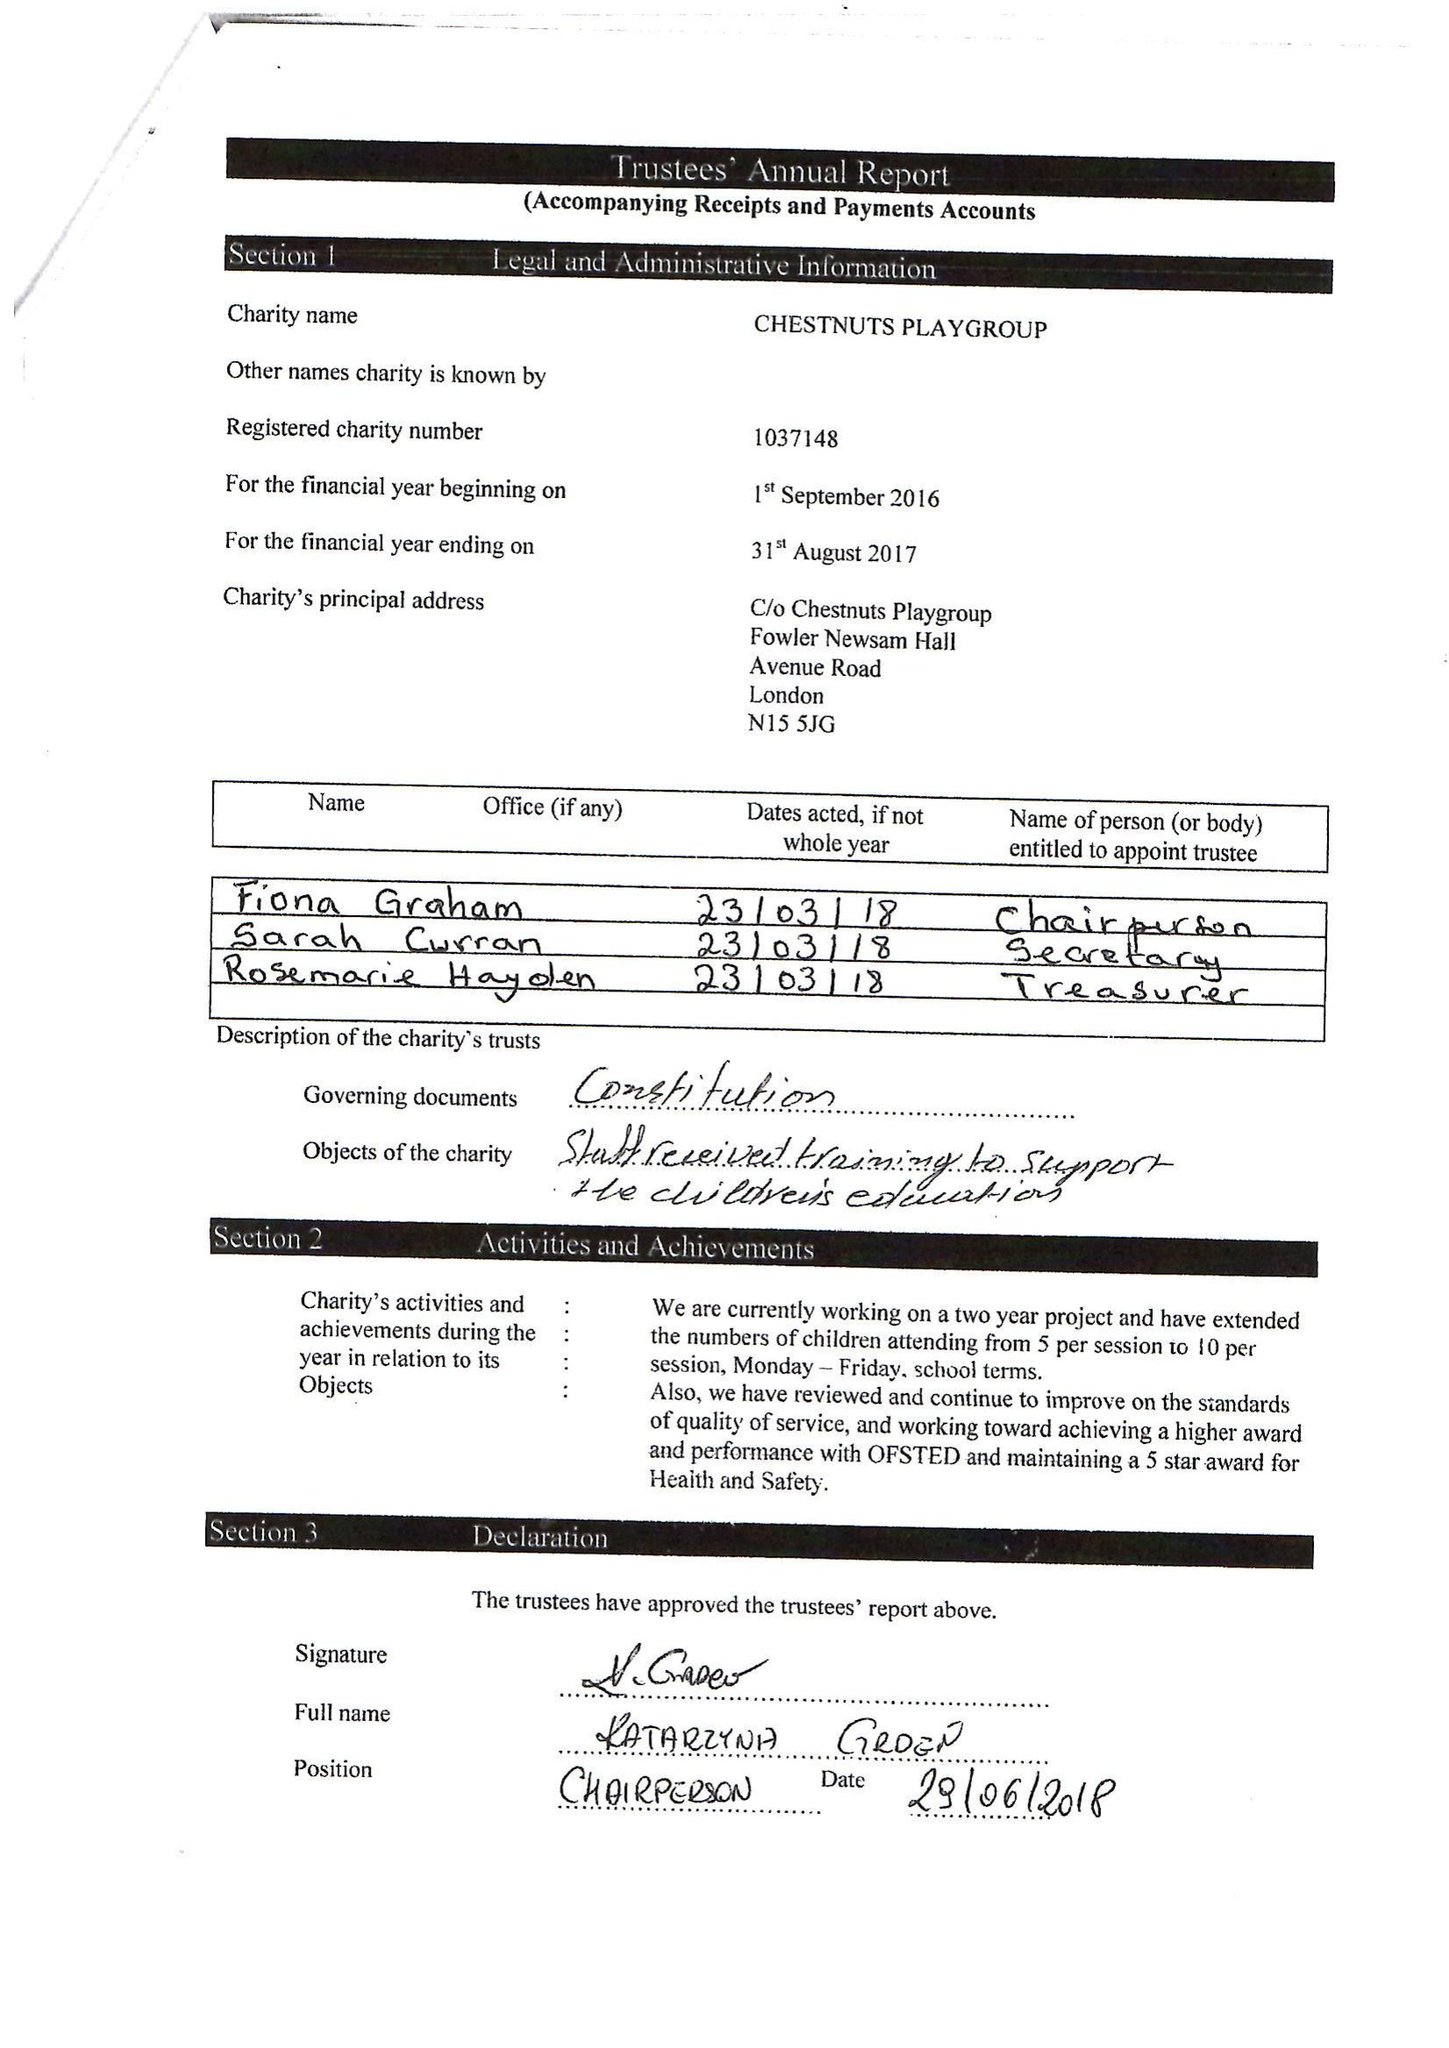What is the value for the charity_name?
Answer the question using a single word or phrase. Chestnuts Playgroup (Haringey) 